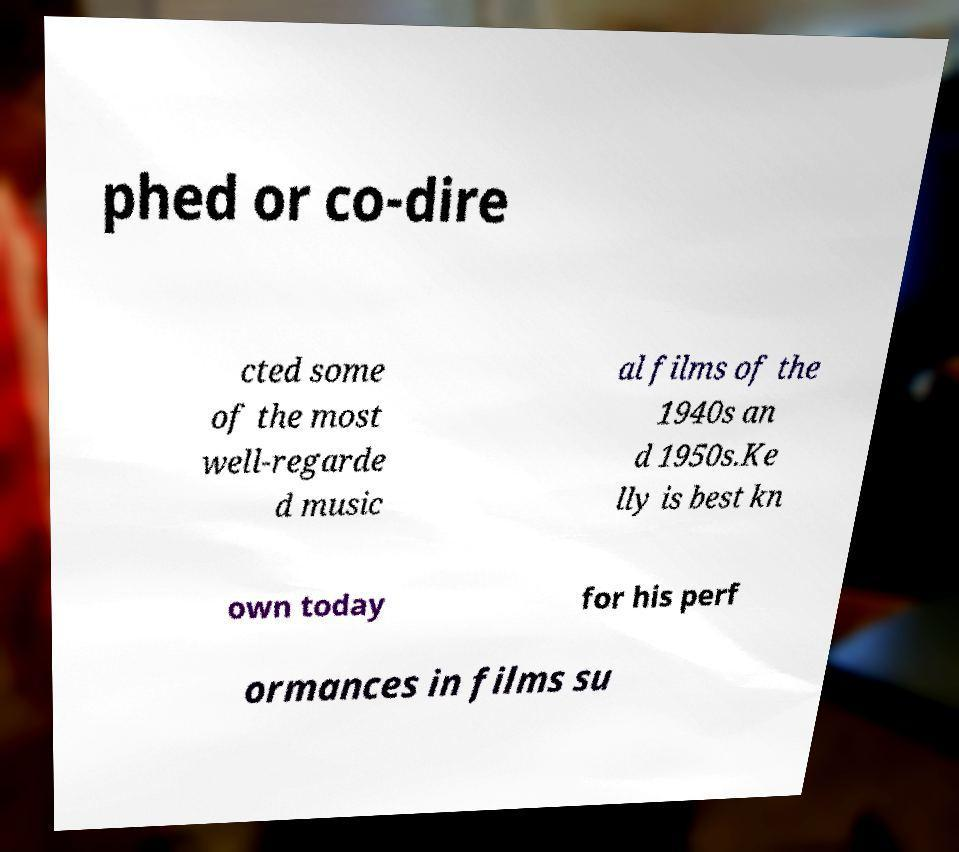I need the written content from this picture converted into text. Can you do that? phed or co-dire cted some of the most well-regarde d music al films of the 1940s an d 1950s.Ke lly is best kn own today for his perf ormances in films su 